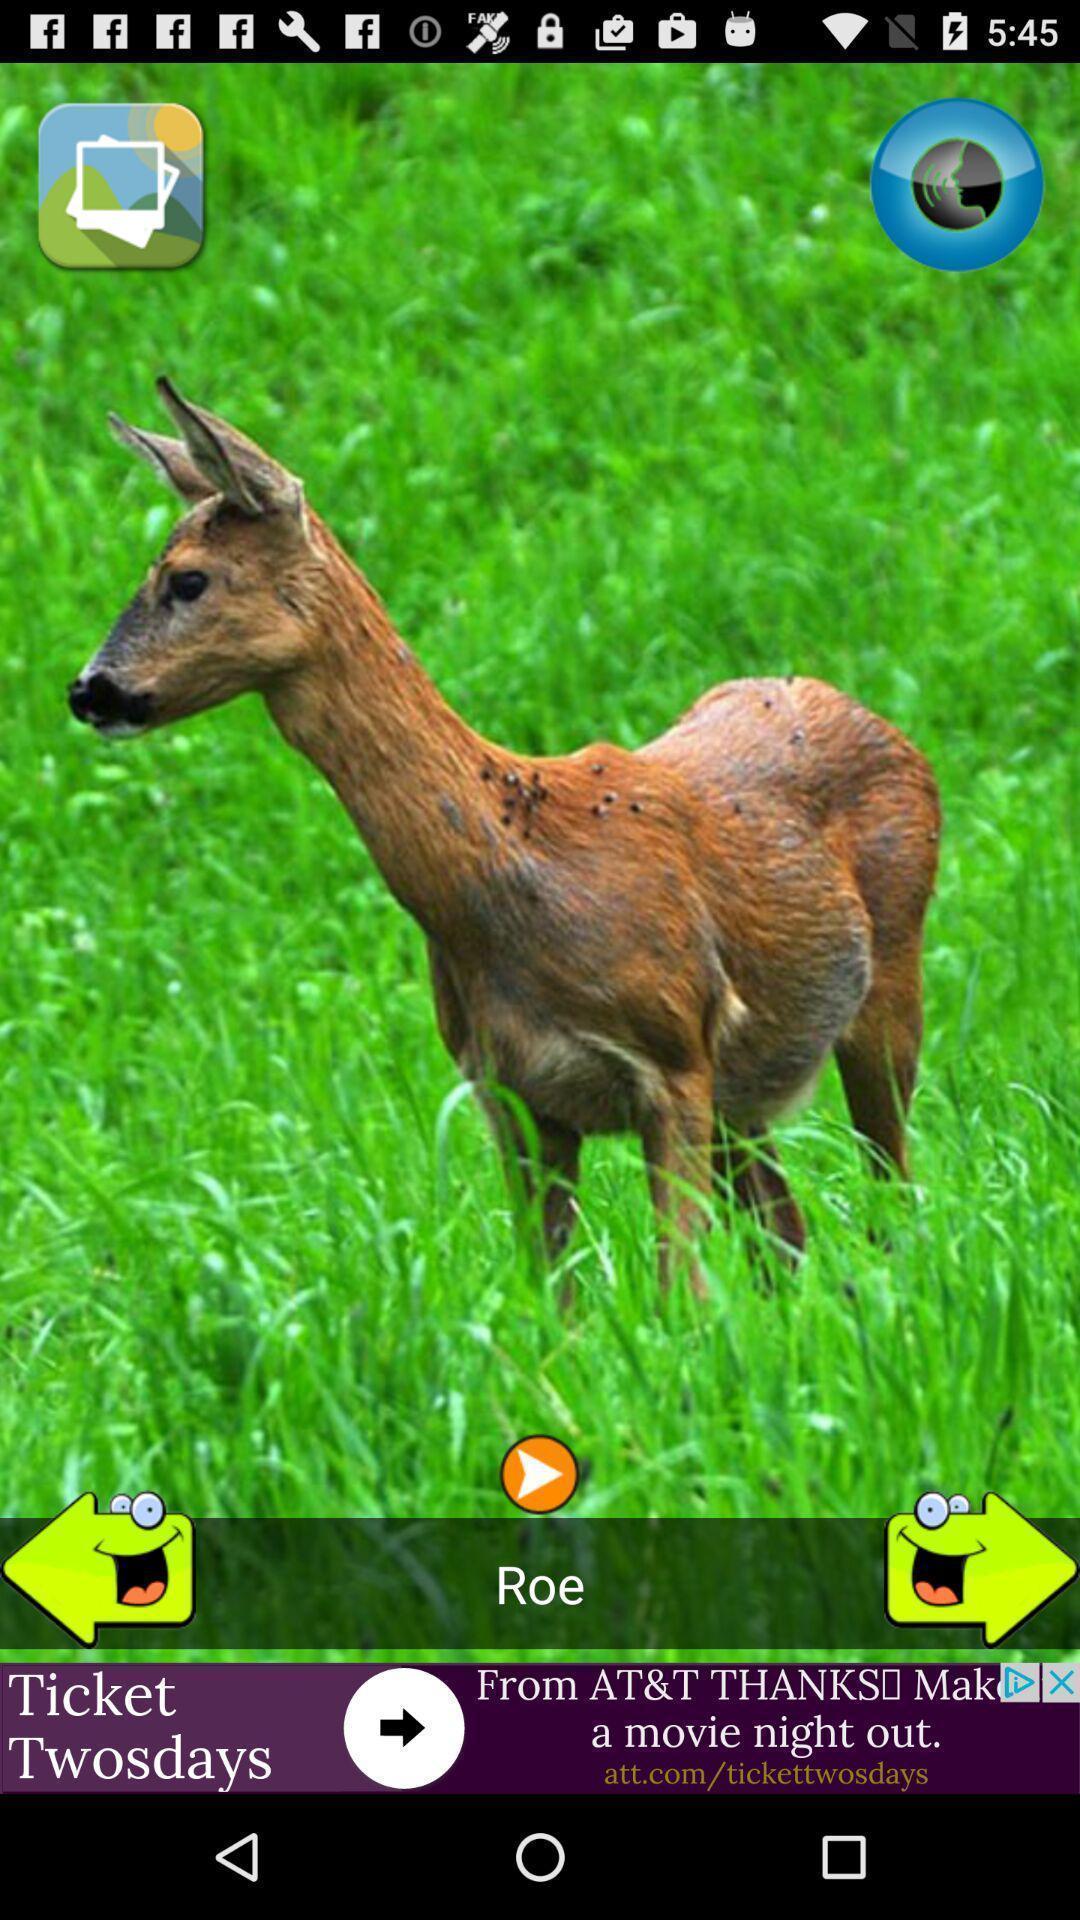Explain the elements present in this screenshot. Screen showing the various animal sounds. 